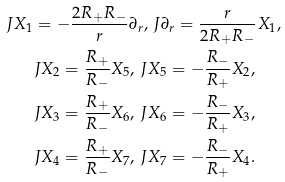Convert formula to latex. <formula><loc_0><loc_0><loc_500><loc_500>J X _ { 1 } & = - \frac { 2 R _ { + } R _ { - } } { r } \partial _ { r } , \, J \partial _ { r } = \frac { r } { 2 R _ { + } R _ { - } } X _ { 1 } , \\ & J X _ { 2 } = \frac { R _ { + } } { R _ { - } } X _ { 5 } , \, J X _ { 5 } = - \frac { R _ { - } } { R _ { + } } X _ { 2 } , \\ & J X _ { 3 } = \frac { R _ { + } } { R _ { - } } X _ { 6 } , \, J X _ { 6 } = - \frac { R _ { - } } { R _ { + } } X _ { 3 } , \\ & J X _ { 4 } = \frac { R _ { + } } { R _ { - } } X _ { 7 } , \, J X _ { 7 } = - \frac { R _ { - } } { R _ { + } } X _ { 4 } .</formula> 